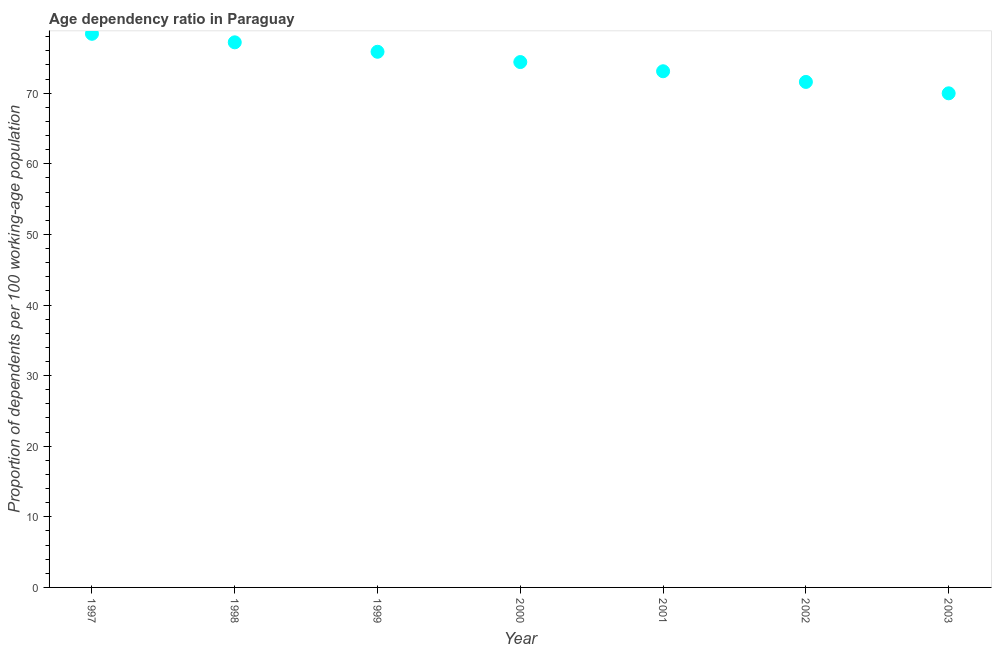What is the age dependency ratio in 1999?
Keep it short and to the point. 75.86. Across all years, what is the maximum age dependency ratio?
Offer a terse response. 78.41. Across all years, what is the minimum age dependency ratio?
Your answer should be very brief. 69.98. In which year was the age dependency ratio minimum?
Provide a short and direct response. 2003. What is the sum of the age dependency ratio?
Give a very brief answer. 520.57. What is the difference between the age dependency ratio in 1998 and 2003?
Provide a short and direct response. 7.22. What is the average age dependency ratio per year?
Offer a very short reply. 74.37. What is the median age dependency ratio?
Keep it short and to the point. 74.41. What is the ratio of the age dependency ratio in 2000 to that in 2003?
Offer a terse response. 1.06. Is the age dependency ratio in 1997 less than that in 2000?
Provide a short and direct response. No. Is the difference between the age dependency ratio in 1998 and 2003 greater than the difference between any two years?
Provide a succinct answer. No. What is the difference between the highest and the second highest age dependency ratio?
Give a very brief answer. 1.21. Is the sum of the age dependency ratio in 1997 and 2002 greater than the maximum age dependency ratio across all years?
Offer a terse response. Yes. What is the difference between the highest and the lowest age dependency ratio?
Your answer should be very brief. 8.43. In how many years, is the age dependency ratio greater than the average age dependency ratio taken over all years?
Your answer should be compact. 4. How many dotlines are there?
Ensure brevity in your answer.  1. What is the difference between two consecutive major ticks on the Y-axis?
Offer a very short reply. 10. What is the title of the graph?
Offer a terse response. Age dependency ratio in Paraguay. What is the label or title of the X-axis?
Keep it short and to the point. Year. What is the label or title of the Y-axis?
Your answer should be compact. Proportion of dependents per 100 working-age population. What is the Proportion of dependents per 100 working-age population in 1997?
Provide a short and direct response. 78.41. What is the Proportion of dependents per 100 working-age population in 1998?
Ensure brevity in your answer.  77.2. What is the Proportion of dependents per 100 working-age population in 1999?
Your response must be concise. 75.86. What is the Proportion of dependents per 100 working-age population in 2000?
Give a very brief answer. 74.41. What is the Proportion of dependents per 100 working-age population in 2001?
Offer a terse response. 73.11. What is the Proportion of dependents per 100 working-age population in 2002?
Keep it short and to the point. 71.59. What is the Proportion of dependents per 100 working-age population in 2003?
Make the answer very short. 69.98. What is the difference between the Proportion of dependents per 100 working-age population in 1997 and 1998?
Give a very brief answer. 1.21. What is the difference between the Proportion of dependents per 100 working-age population in 1997 and 1999?
Ensure brevity in your answer.  2.55. What is the difference between the Proportion of dependents per 100 working-age population in 1997 and 2000?
Your response must be concise. 4. What is the difference between the Proportion of dependents per 100 working-age population in 1997 and 2001?
Give a very brief answer. 5.3. What is the difference between the Proportion of dependents per 100 working-age population in 1997 and 2002?
Provide a succinct answer. 6.82. What is the difference between the Proportion of dependents per 100 working-age population in 1997 and 2003?
Offer a terse response. 8.43. What is the difference between the Proportion of dependents per 100 working-age population in 1998 and 1999?
Your answer should be compact. 1.34. What is the difference between the Proportion of dependents per 100 working-age population in 1998 and 2000?
Keep it short and to the point. 2.79. What is the difference between the Proportion of dependents per 100 working-age population in 1998 and 2001?
Give a very brief answer. 4.1. What is the difference between the Proportion of dependents per 100 working-age population in 1998 and 2002?
Provide a succinct answer. 5.61. What is the difference between the Proportion of dependents per 100 working-age population in 1998 and 2003?
Offer a very short reply. 7.22. What is the difference between the Proportion of dependents per 100 working-age population in 1999 and 2000?
Give a very brief answer. 1.46. What is the difference between the Proportion of dependents per 100 working-age population in 1999 and 2001?
Your response must be concise. 2.76. What is the difference between the Proportion of dependents per 100 working-age population in 1999 and 2002?
Keep it short and to the point. 4.27. What is the difference between the Proportion of dependents per 100 working-age population in 1999 and 2003?
Provide a succinct answer. 5.88. What is the difference between the Proportion of dependents per 100 working-age population in 2000 and 2001?
Provide a short and direct response. 1.3. What is the difference between the Proportion of dependents per 100 working-age population in 2000 and 2002?
Your answer should be compact. 2.81. What is the difference between the Proportion of dependents per 100 working-age population in 2000 and 2003?
Your response must be concise. 4.43. What is the difference between the Proportion of dependents per 100 working-age population in 2001 and 2002?
Ensure brevity in your answer.  1.51. What is the difference between the Proportion of dependents per 100 working-age population in 2001 and 2003?
Make the answer very short. 3.12. What is the difference between the Proportion of dependents per 100 working-age population in 2002 and 2003?
Keep it short and to the point. 1.61. What is the ratio of the Proportion of dependents per 100 working-age population in 1997 to that in 1999?
Keep it short and to the point. 1.03. What is the ratio of the Proportion of dependents per 100 working-age population in 1997 to that in 2000?
Your answer should be very brief. 1.05. What is the ratio of the Proportion of dependents per 100 working-age population in 1997 to that in 2001?
Your answer should be compact. 1.07. What is the ratio of the Proportion of dependents per 100 working-age population in 1997 to that in 2002?
Make the answer very short. 1.09. What is the ratio of the Proportion of dependents per 100 working-age population in 1997 to that in 2003?
Provide a succinct answer. 1.12. What is the ratio of the Proportion of dependents per 100 working-age population in 1998 to that in 2000?
Offer a very short reply. 1.04. What is the ratio of the Proportion of dependents per 100 working-age population in 1998 to that in 2001?
Provide a short and direct response. 1.06. What is the ratio of the Proportion of dependents per 100 working-age population in 1998 to that in 2002?
Provide a succinct answer. 1.08. What is the ratio of the Proportion of dependents per 100 working-age population in 1998 to that in 2003?
Offer a terse response. 1.1. What is the ratio of the Proportion of dependents per 100 working-age population in 1999 to that in 2001?
Your answer should be compact. 1.04. What is the ratio of the Proportion of dependents per 100 working-age population in 1999 to that in 2002?
Provide a succinct answer. 1.06. What is the ratio of the Proportion of dependents per 100 working-age population in 1999 to that in 2003?
Your answer should be very brief. 1.08. What is the ratio of the Proportion of dependents per 100 working-age population in 2000 to that in 2002?
Ensure brevity in your answer.  1.04. What is the ratio of the Proportion of dependents per 100 working-age population in 2000 to that in 2003?
Provide a succinct answer. 1.06. What is the ratio of the Proportion of dependents per 100 working-age population in 2001 to that in 2002?
Offer a terse response. 1.02. What is the ratio of the Proportion of dependents per 100 working-age population in 2001 to that in 2003?
Offer a terse response. 1.04. What is the ratio of the Proportion of dependents per 100 working-age population in 2002 to that in 2003?
Provide a succinct answer. 1.02. 